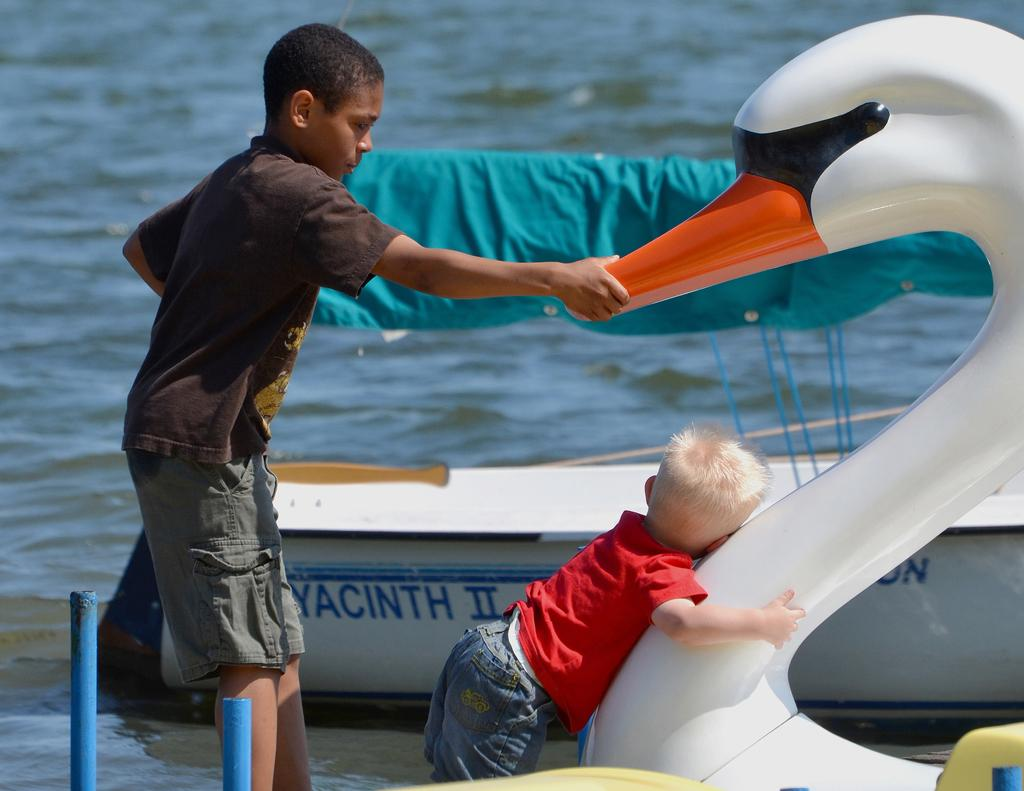How many people are in the image? There are two persons in the image. What are the two persons doing in the image? The two persons are holding a boat. Can you describe the background of the image? There is a boat and water visible in the background of the image. What type of coat is the boat wearing in the image? There is no coat present in the image, as boats do not wear clothing. 